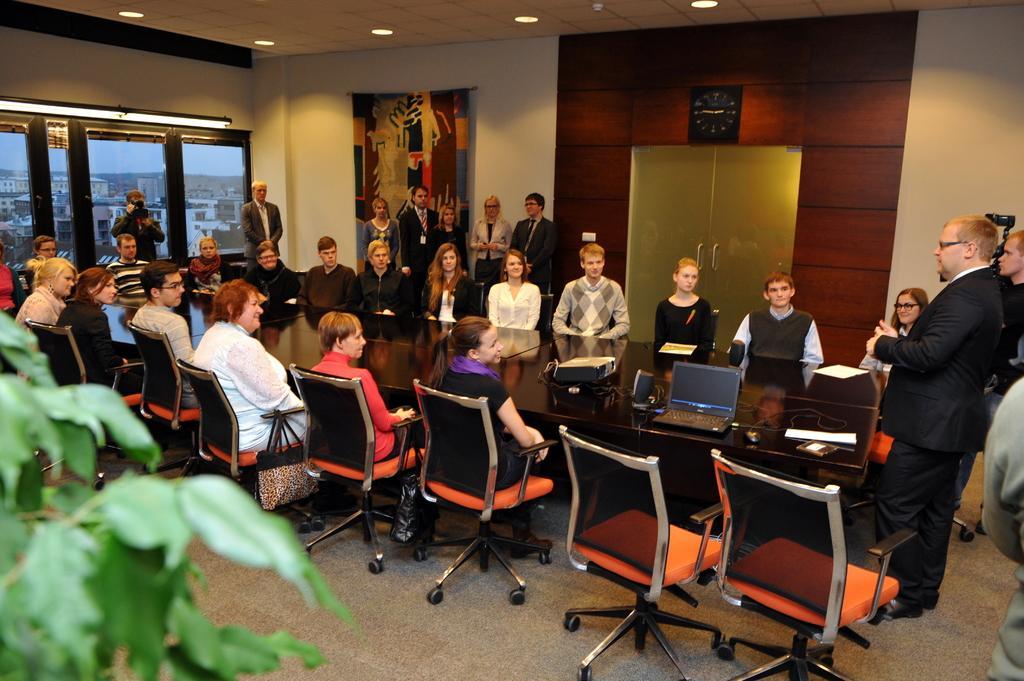In one or two sentences, can you explain what this image depicts? In the image there are group of people sitting on chair in front of a table, on table we can see a projector,speaker,laptop,wire,paper. On right side there is a man wearing a black color suit is standing and there is another man holding a camera and standing and there are group of people standing on left side. 